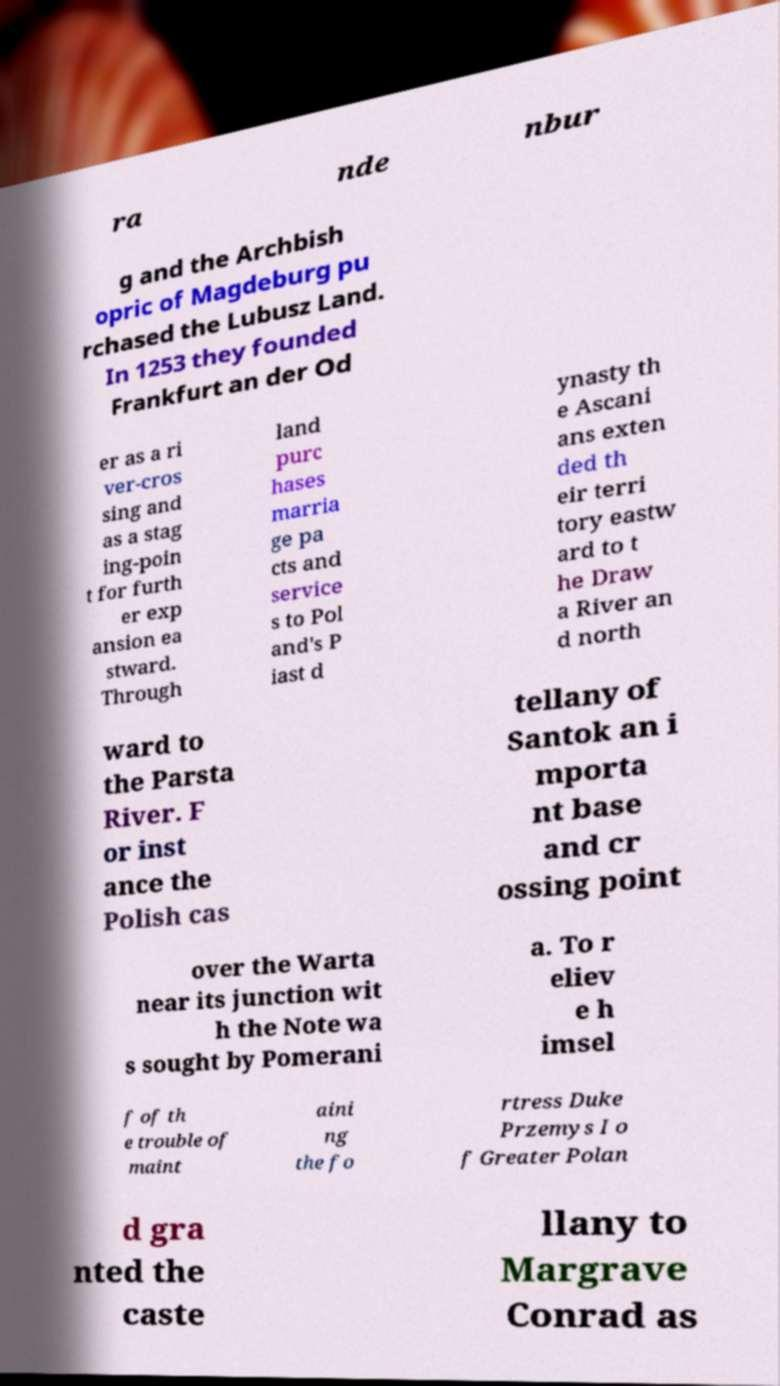For documentation purposes, I need the text within this image transcribed. Could you provide that? ra nde nbur g and the Archbish opric of Magdeburg pu rchased the Lubusz Land. In 1253 they founded Frankfurt an der Od er as a ri ver-cros sing and as a stag ing-poin t for furth er exp ansion ea stward. Through land purc hases marria ge pa cts and service s to Pol and's P iast d ynasty th e Ascani ans exten ded th eir terri tory eastw ard to t he Draw a River an d north ward to the Parsta River. F or inst ance the Polish cas tellany of Santok an i mporta nt base and cr ossing point over the Warta near its junction wit h the Note wa s sought by Pomerani a. To r eliev e h imsel f of th e trouble of maint aini ng the fo rtress Duke Przemys I o f Greater Polan d gra nted the caste llany to Margrave Conrad as 